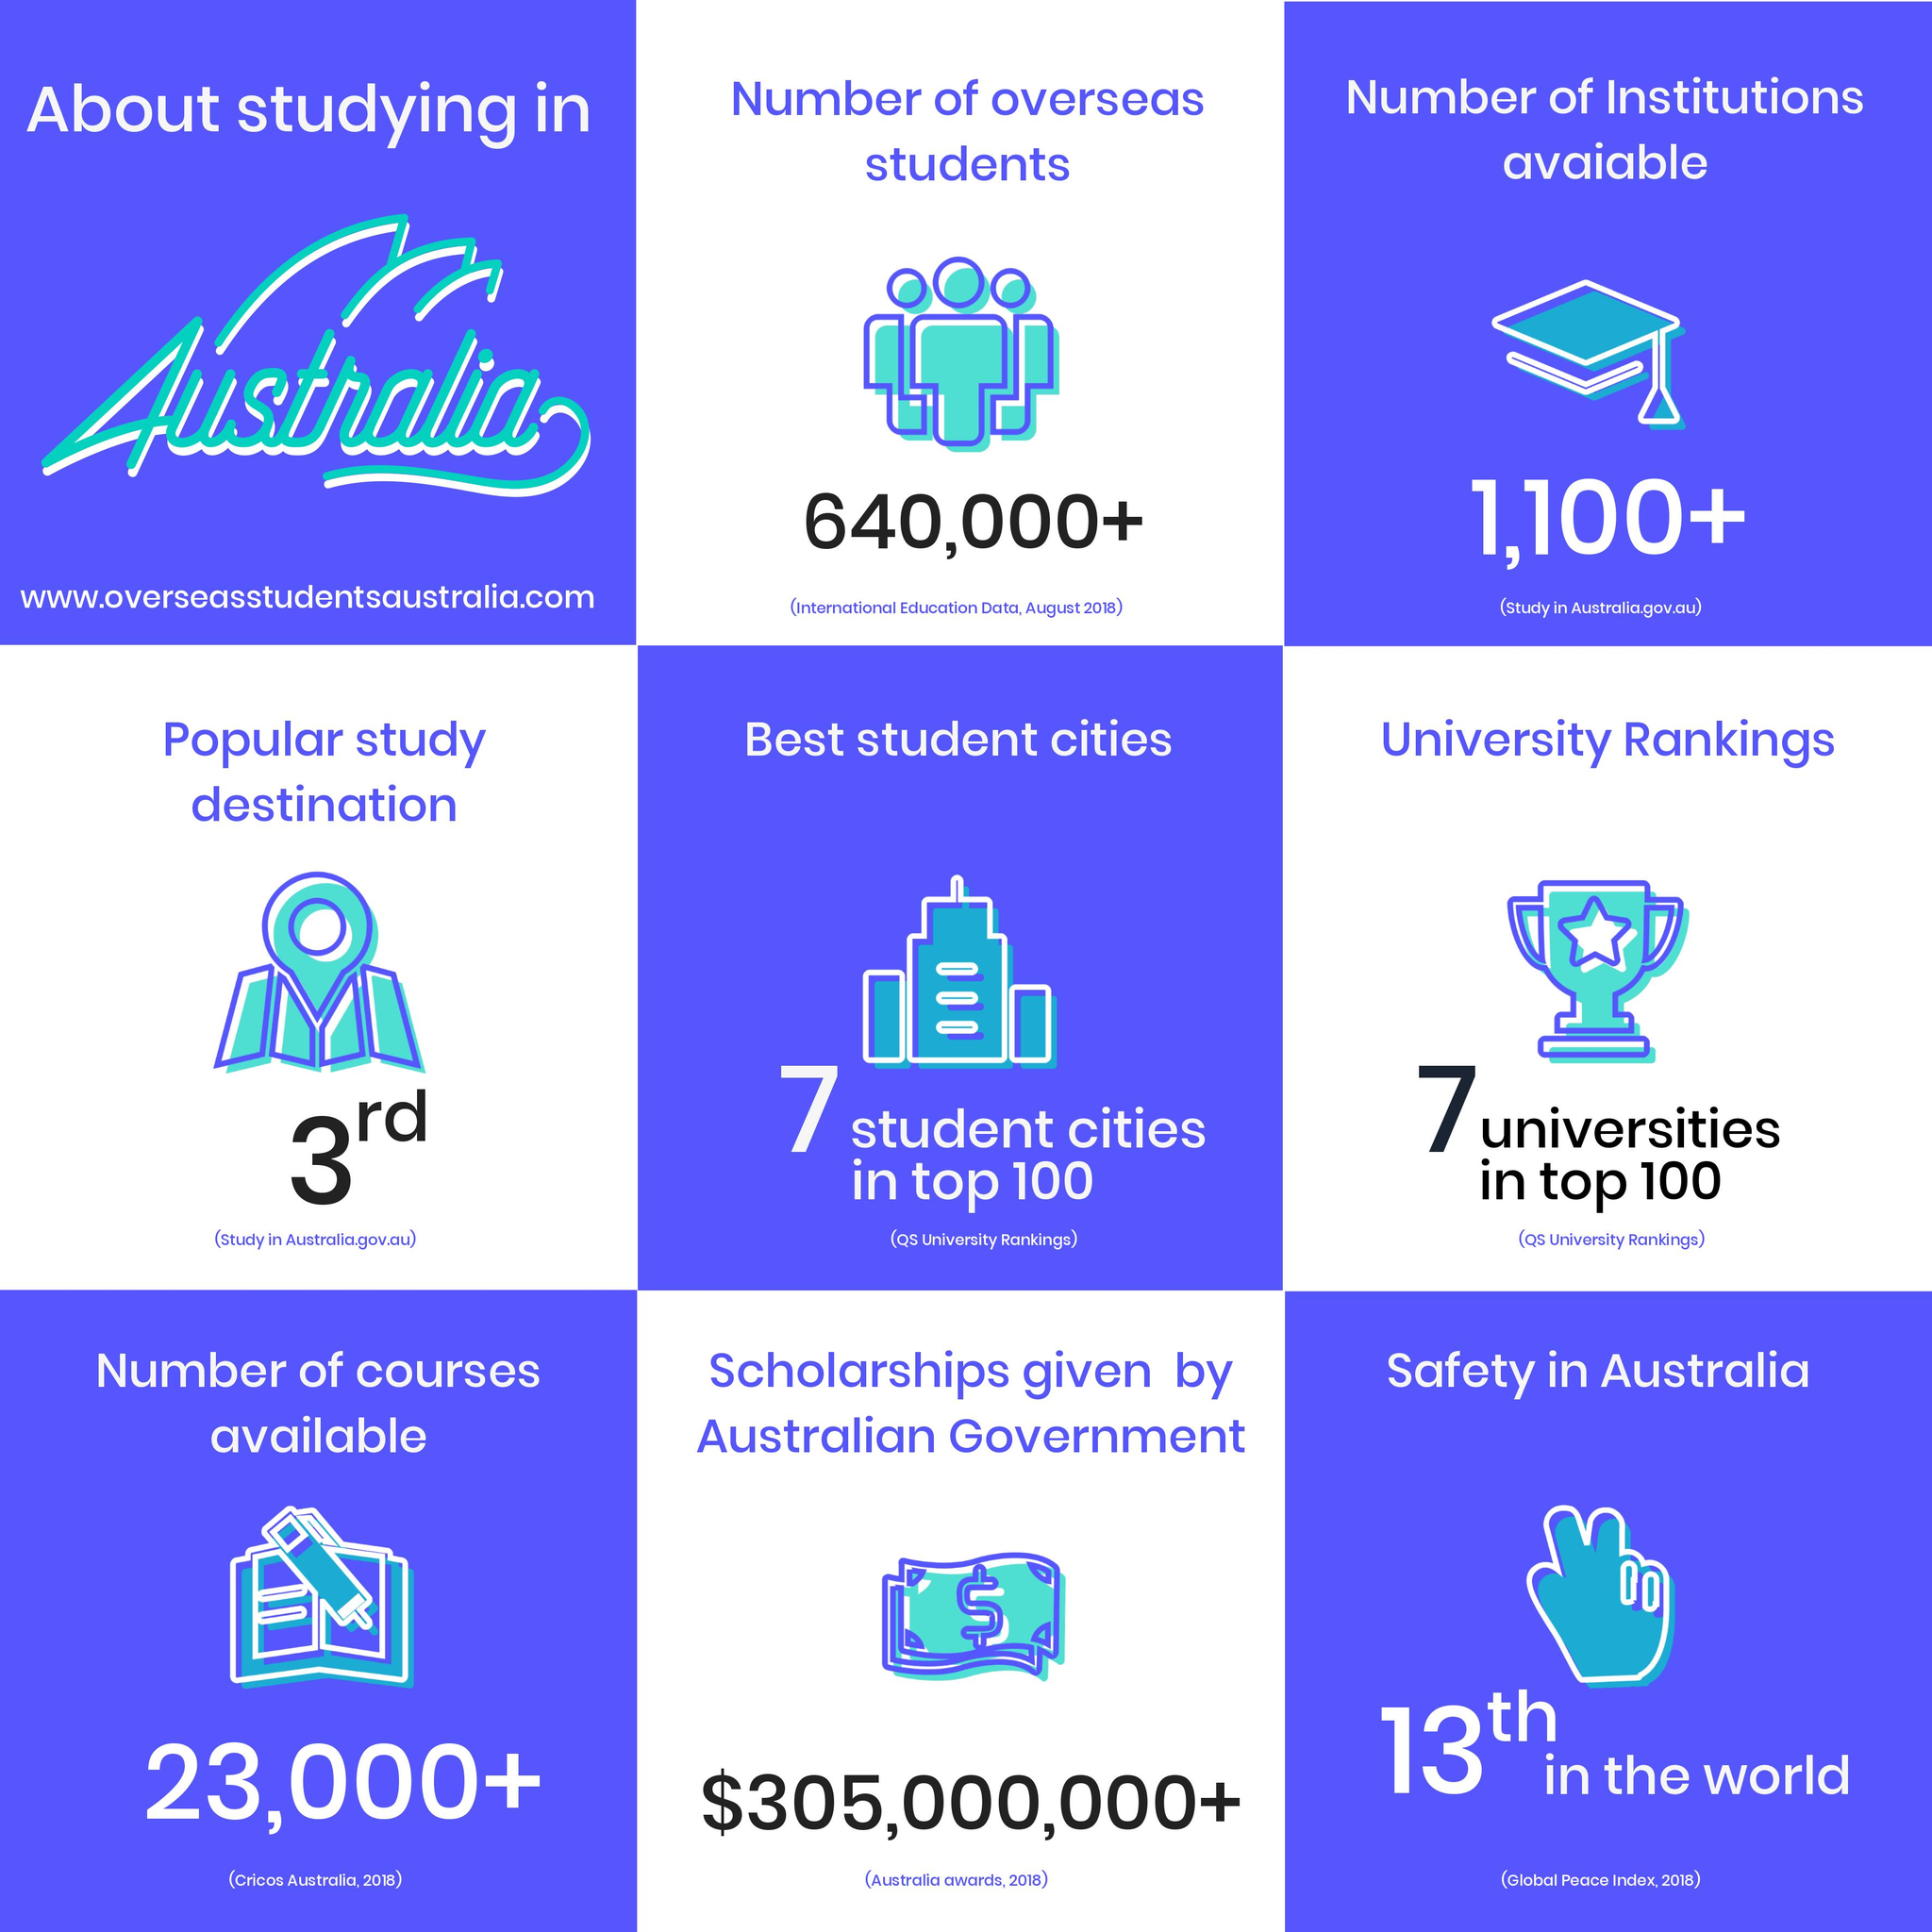Outline some significant characteristics in this image. In 2018, there were more than 23,000 different courses available in Australia. As of August 2018, it is estimated that over 640,000+ overseas students are currently studying in Australia. In 2018, the Australian government awarded a total of $305,000,000 or more in scholarships. There are over 1,100 institutions available in Australia. 